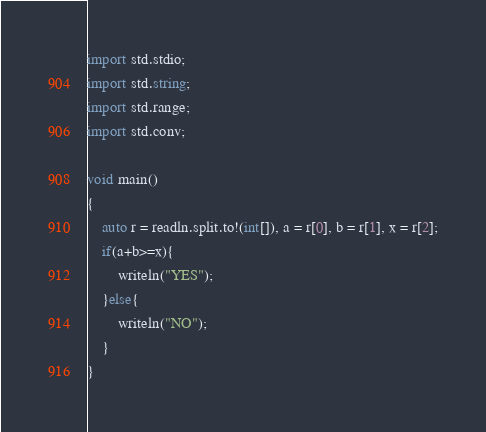Convert code to text. <code><loc_0><loc_0><loc_500><loc_500><_D_>import std.stdio;
import std.string;
import std.range;
import std.conv;

void main()
{
	auto r = readln.split.to!(int[]), a = r[0], b = r[1], x = r[2];
    if(a+b>=x){
    	writeln("YES");
    }else{
    	writeln("NO");
    }
}</code> 